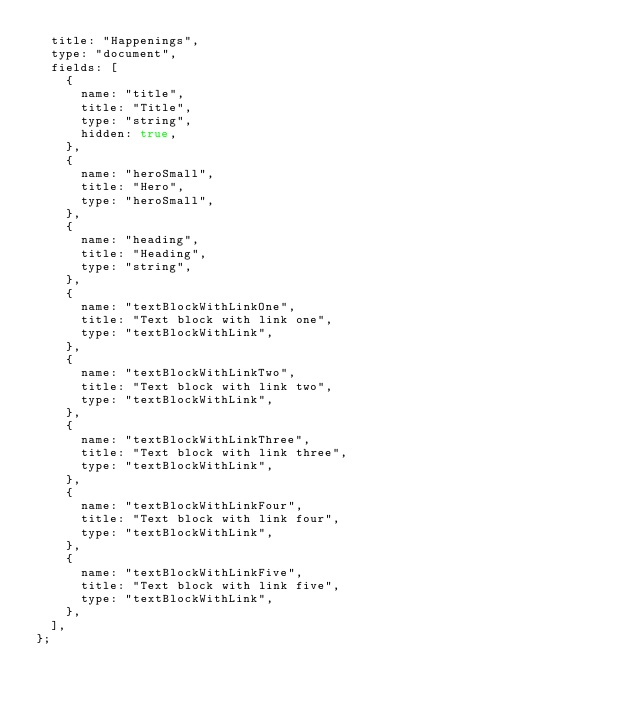Convert code to text. <code><loc_0><loc_0><loc_500><loc_500><_JavaScript_>  title: "Happenings",
  type: "document",
  fields: [
    {
      name: "title",
      title: "Title",
      type: "string",
      hidden: true,
    },
    {
      name: "heroSmall",
      title: "Hero",
      type: "heroSmall",
    },
    {
      name: "heading",
      title: "Heading",
      type: "string",
    },
    {
      name: "textBlockWithLinkOne",
      title: "Text block with link one",
      type: "textBlockWithLink",
    },
    {
      name: "textBlockWithLinkTwo",
      title: "Text block with link two",
      type: "textBlockWithLink",
    },
    {
      name: "textBlockWithLinkThree",
      title: "Text block with link three",
      type: "textBlockWithLink",
    },
    {
      name: "textBlockWithLinkFour",
      title: "Text block with link four",
      type: "textBlockWithLink",
    },
    {
      name: "textBlockWithLinkFive",
      title: "Text block with link five",
      type: "textBlockWithLink",
    },
  ],
};
</code> 